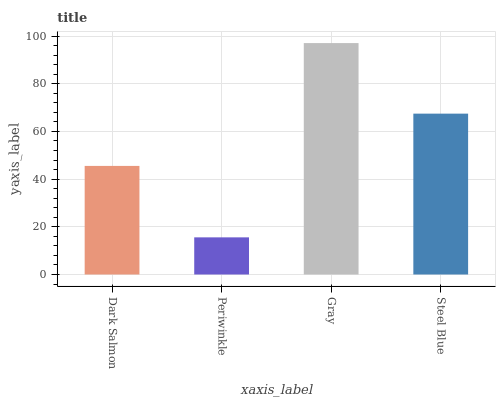Is Gray the minimum?
Answer yes or no. No. Is Periwinkle the maximum?
Answer yes or no. No. Is Gray greater than Periwinkle?
Answer yes or no. Yes. Is Periwinkle less than Gray?
Answer yes or no. Yes. Is Periwinkle greater than Gray?
Answer yes or no. No. Is Gray less than Periwinkle?
Answer yes or no. No. Is Steel Blue the high median?
Answer yes or no. Yes. Is Dark Salmon the low median?
Answer yes or no. Yes. Is Gray the high median?
Answer yes or no. No. Is Gray the low median?
Answer yes or no. No. 